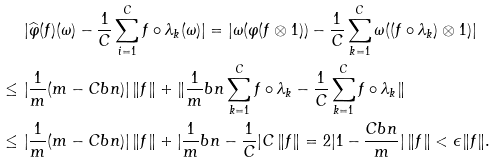<formula> <loc_0><loc_0><loc_500><loc_500>& | \widehat { \varphi } ( f ) ( \omega ) - \frac { 1 } { C } \sum _ { i = 1 } ^ { C } f \circ \lambda _ { k } ( \omega ) | = | \omega ( \varphi ( f \otimes 1 ) ) - \frac { 1 } { C } \sum _ { k = 1 } ^ { C } \omega ( ( f \circ \lambda _ { k } ) \otimes 1 ) | \\ \leq \ & | \frac { 1 } { m } ( m - C b n ) | \, \| f \| + \| \frac { 1 } { m } b n \sum _ { k = 1 } ^ { C } f \circ \lambda _ { k } - \frac { 1 } { C } \sum _ { k = 1 } ^ { C } f \circ \lambda _ { k } \| \\ \leq \ & | \frac { 1 } { m } ( m - C b n ) | \, \| f \| + | \frac { 1 } { m } b n - \frac { 1 } { C } | C \, \| f \| = 2 | 1 - \frac { C b n } m | \, \| f \| < \epsilon \| f \| . \\</formula> 